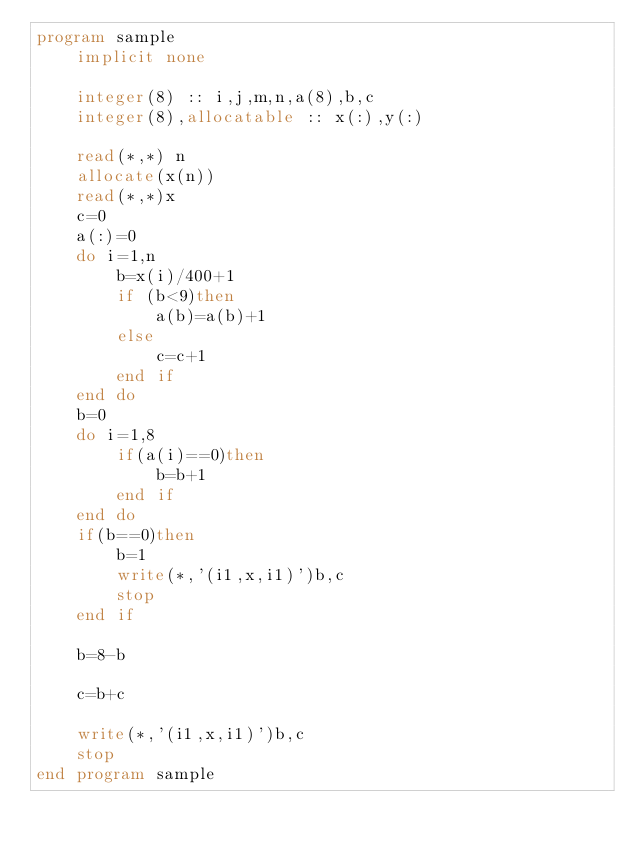Convert code to text. <code><loc_0><loc_0><loc_500><loc_500><_FORTRAN_>program sample
    implicit none
  
    integer(8) :: i,j,m,n,a(8),b,c
    integer(8),allocatable :: x(:),y(:)
  
    read(*,*) n
    allocate(x(n))
    read(*,*)x
    c=0
    a(:)=0
    do i=1,n
        b=x(i)/400+1
        if (b<9)then
            a(b)=a(b)+1
        else
            c=c+1
        end if
    end do
    b=0
    do i=1,8
        if(a(i)==0)then
            b=b+1
        end if
    end do
    if(b==0)then
        b=1
        write(*,'(i1,x,i1)')b,c
        stop
    end if

    b=8-b
    
    c=b+c
    
    write(*,'(i1,x,i1)')b,c
    stop
end program sample
  

</code> 